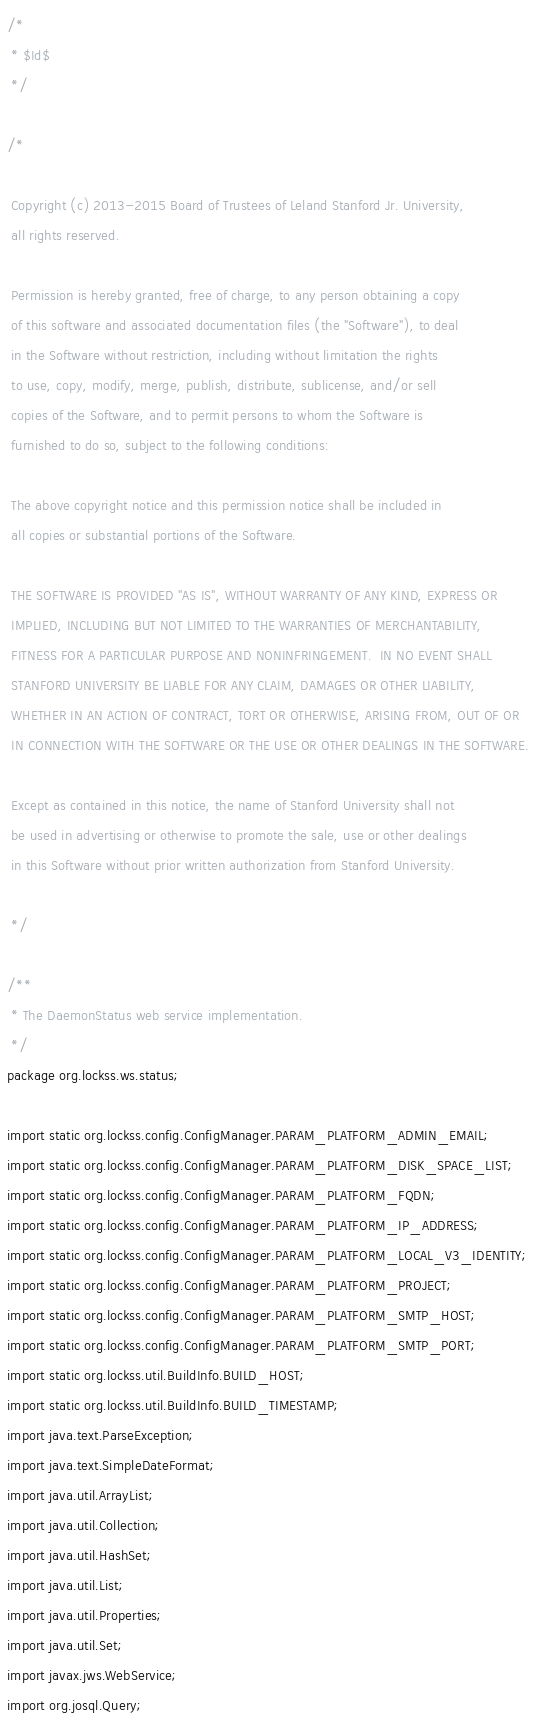<code> <loc_0><loc_0><loc_500><loc_500><_Java_>/*
 * $Id$
 */

/*

 Copyright (c) 2013-2015 Board of Trustees of Leland Stanford Jr. University,
 all rights reserved.

 Permission is hereby granted, free of charge, to any person obtaining a copy
 of this software and associated documentation files (the "Software"), to deal
 in the Software without restriction, including without limitation the rights
 to use, copy, modify, merge, publish, distribute, sublicense, and/or sell
 copies of the Software, and to permit persons to whom the Software is
 furnished to do so, subject to the following conditions:

 The above copyright notice and this permission notice shall be included in
 all copies or substantial portions of the Software.

 THE SOFTWARE IS PROVIDED "AS IS", WITHOUT WARRANTY OF ANY KIND, EXPRESS OR
 IMPLIED, INCLUDING BUT NOT LIMITED TO THE WARRANTIES OF MERCHANTABILITY,
 FITNESS FOR A PARTICULAR PURPOSE AND NONINFRINGEMENT.  IN NO EVENT SHALL
 STANFORD UNIVERSITY BE LIABLE FOR ANY CLAIM, DAMAGES OR OTHER LIABILITY,
 WHETHER IN AN ACTION OF CONTRACT, TORT OR OTHERWISE, ARISING FROM, OUT OF OR
 IN CONNECTION WITH THE SOFTWARE OR THE USE OR OTHER DEALINGS IN THE SOFTWARE.

 Except as contained in this notice, the name of Stanford University shall not
 be used in advertising or otherwise to promote the sale, use or other dealings
 in this Software without prior written authorization from Stanford University.

 */

/**
 * The DaemonStatus web service implementation.
 */
package org.lockss.ws.status;

import static org.lockss.config.ConfigManager.PARAM_PLATFORM_ADMIN_EMAIL;
import static org.lockss.config.ConfigManager.PARAM_PLATFORM_DISK_SPACE_LIST;
import static org.lockss.config.ConfigManager.PARAM_PLATFORM_FQDN;
import static org.lockss.config.ConfigManager.PARAM_PLATFORM_IP_ADDRESS;
import static org.lockss.config.ConfigManager.PARAM_PLATFORM_LOCAL_V3_IDENTITY;
import static org.lockss.config.ConfigManager.PARAM_PLATFORM_PROJECT;
import static org.lockss.config.ConfigManager.PARAM_PLATFORM_SMTP_HOST;
import static org.lockss.config.ConfigManager.PARAM_PLATFORM_SMTP_PORT;
import static org.lockss.util.BuildInfo.BUILD_HOST;
import static org.lockss.util.BuildInfo.BUILD_TIMESTAMP;
import java.text.ParseException;
import java.text.SimpleDateFormat;
import java.util.ArrayList;
import java.util.Collection;
import java.util.HashSet;
import java.util.List;
import java.util.Properties;
import java.util.Set;
import javax.jws.WebService;
import org.josql.Query;</code> 